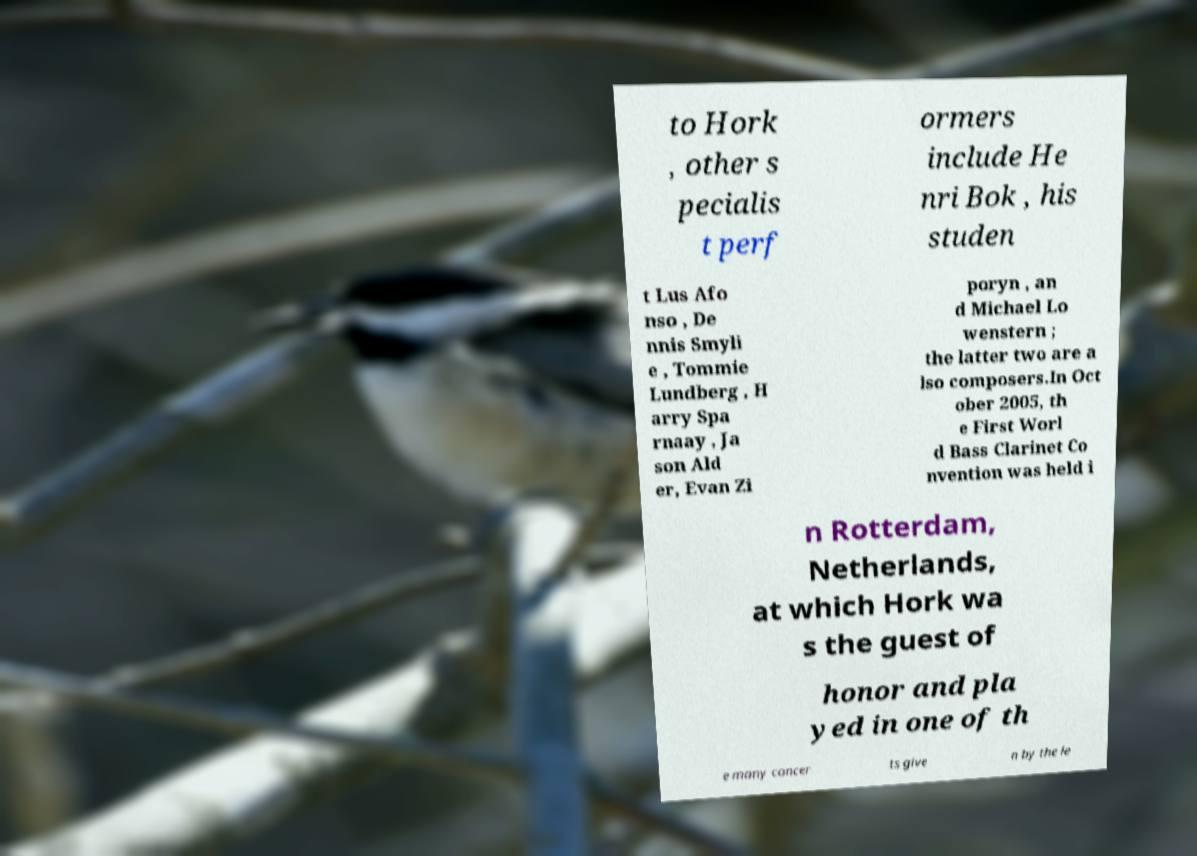Please read and relay the text visible in this image. What does it say? to Hork , other s pecialis t perf ormers include He nri Bok , his studen t Lus Afo nso , De nnis Smyli e , Tommie Lundberg , H arry Spa rnaay , Ja son Ald er, Evan Zi poryn , an d Michael Lo wenstern ; the latter two are a lso composers.In Oct ober 2005, th e First Worl d Bass Clarinet Co nvention was held i n Rotterdam, Netherlands, at which Hork wa s the guest of honor and pla yed in one of th e many concer ts give n by the le 